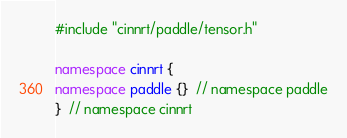Convert code to text. <code><loc_0><loc_0><loc_500><loc_500><_C++_>#include "cinnrt/paddle/tensor.h"

namespace cinnrt {
namespace paddle {}  // namespace paddle
}  // namespace cinnrt
</code> 